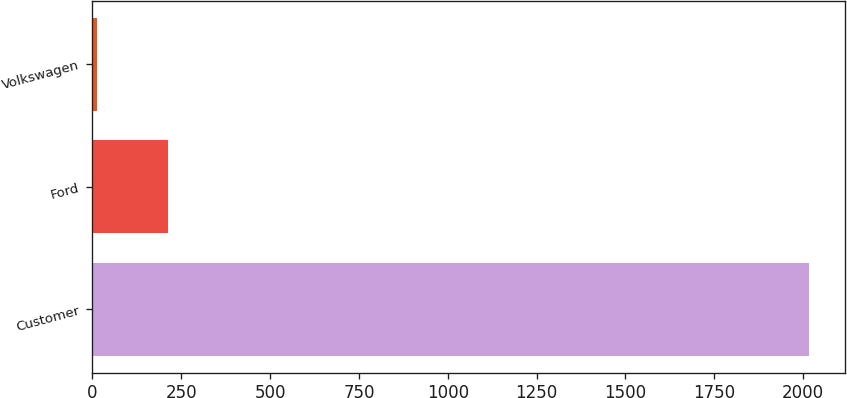Convert chart. <chart><loc_0><loc_0><loc_500><loc_500><bar_chart><fcel>Customer<fcel>Ford<fcel>Volkswagen<nl><fcel>2018<fcel>212.6<fcel>12<nl></chart> 